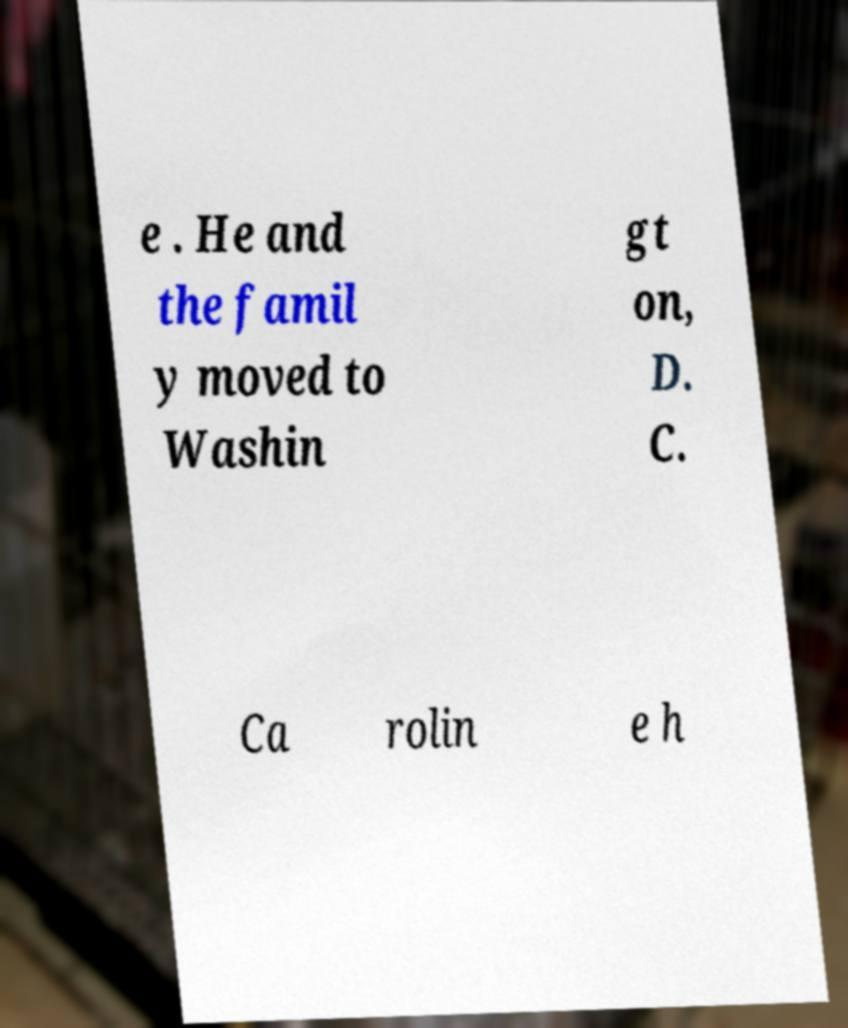Can you accurately transcribe the text from the provided image for me? e . He and the famil y moved to Washin gt on, D. C. Ca rolin e h 